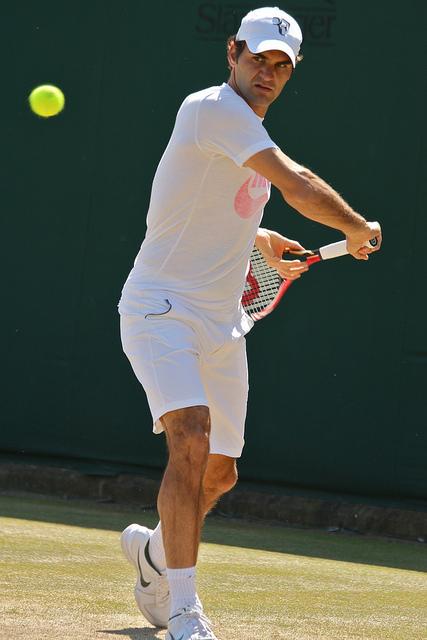What brand of sneakers is he wearing?
Answer briefly. Nike. Will he be able to hit the ball?
Answer briefly. Yes. Is the man in motion?
Short answer required. Yes. 